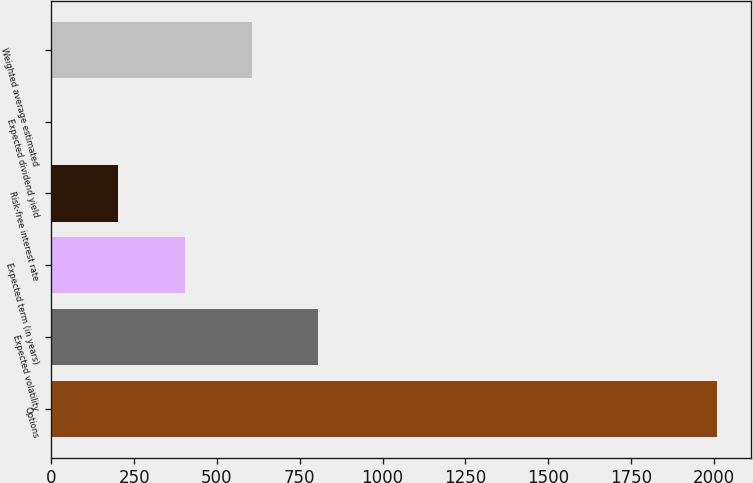Convert chart to OTSL. <chart><loc_0><loc_0><loc_500><loc_500><bar_chart><fcel>Options<fcel>Expected volatility<fcel>Expected term (in years)<fcel>Risk-free interest rate<fcel>Expected dividend yield<fcel>Weighted average estimated<nl><fcel>2011<fcel>805.36<fcel>403.48<fcel>202.54<fcel>1.6<fcel>604.42<nl></chart> 